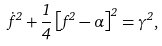Convert formula to latex. <formula><loc_0><loc_0><loc_500><loc_500>\dot { f } ^ { 2 } + \frac { 1 } { 4 } \left [ f ^ { 2 } - \alpha \right ] ^ { 2 } = \gamma ^ { 2 } ,</formula> 